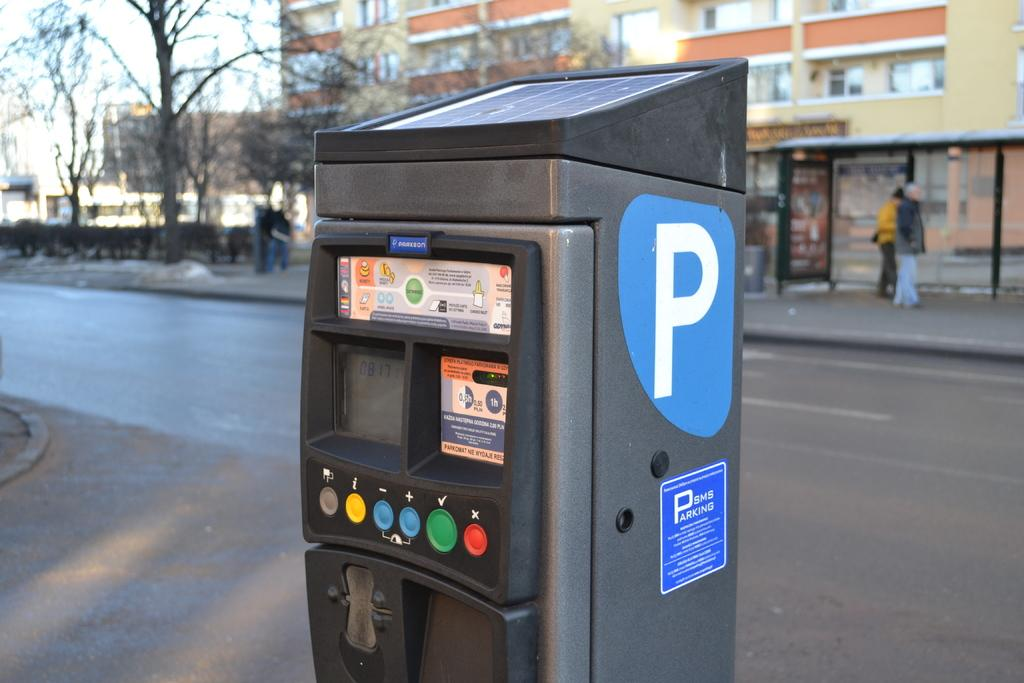<image>
Describe the image concisely. A digital payment kiosk for parking payments, the screen shows 8:17.. 